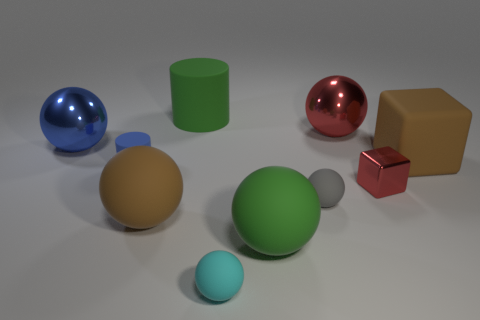What number of things are brown matte objects to the left of the green matte sphere or matte spheres that are on the right side of the cyan ball?
Provide a succinct answer. 3. There is a large matte ball on the right side of the brown sphere; does it have the same color as the matte cylinder that is on the right side of the blue rubber cylinder?
Provide a short and direct response. Yes. What is the shape of the large rubber object that is left of the small red metallic thing and behind the tiny blue thing?
Offer a terse response. Cylinder. There is another sphere that is the same size as the gray rubber ball; what is its color?
Give a very brief answer. Cyan. Is there a large rubber sphere of the same color as the big block?
Provide a short and direct response. Yes. There is a green matte thing in front of the brown block; is it the same size as the metal thing in front of the big blue metallic sphere?
Ensure brevity in your answer.  No. The object that is right of the small gray thing and in front of the tiny cylinder is made of what material?
Offer a very short reply. Metal. What is the size of the ball that is the same color as the tiny shiny thing?
Make the answer very short. Large. How many other things are the same size as the red metallic block?
Provide a succinct answer. 3. There is a red object that is behind the small red thing; what is it made of?
Provide a succinct answer. Metal. 